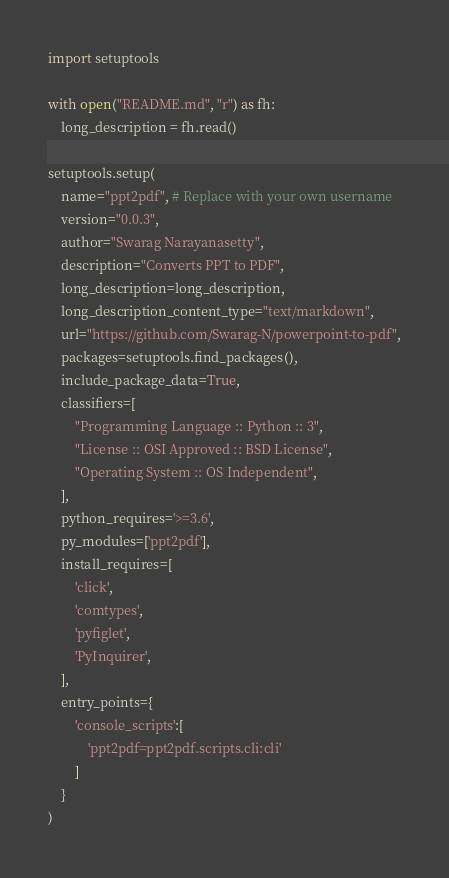Convert code to text. <code><loc_0><loc_0><loc_500><loc_500><_Python_>import setuptools

with open("README.md", "r") as fh:
    long_description = fh.read()

setuptools.setup(
    name="ppt2pdf", # Replace with your own username
    version="0.0.3",
    author="Swarag Narayanasetty",
    description="Converts PPT to PDF",
    long_description=long_description,
    long_description_content_type="text/markdown",
    url="https://github.com/Swarag-N/powerpoint-to-pdf",
    packages=setuptools.find_packages(),
    include_package_data=True,
    classifiers=[
        "Programming Language :: Python :: 3",
        "License :: OSI Approved :: BSD License",
        "Operating System :: OS Independent",
    ],
    python_requires='>=3.6',
    py_modules=['ppt2pdf'],
    install_requires=[
        'click',
        'comtypes',
        'pyfiglet',
        'PyInquirer',
    ],
    entry_points={
        'console_scripts':[
            'ppt2pdf=ppt2pdf.scripts.cli:cli'
        ]
    }
)</code> 